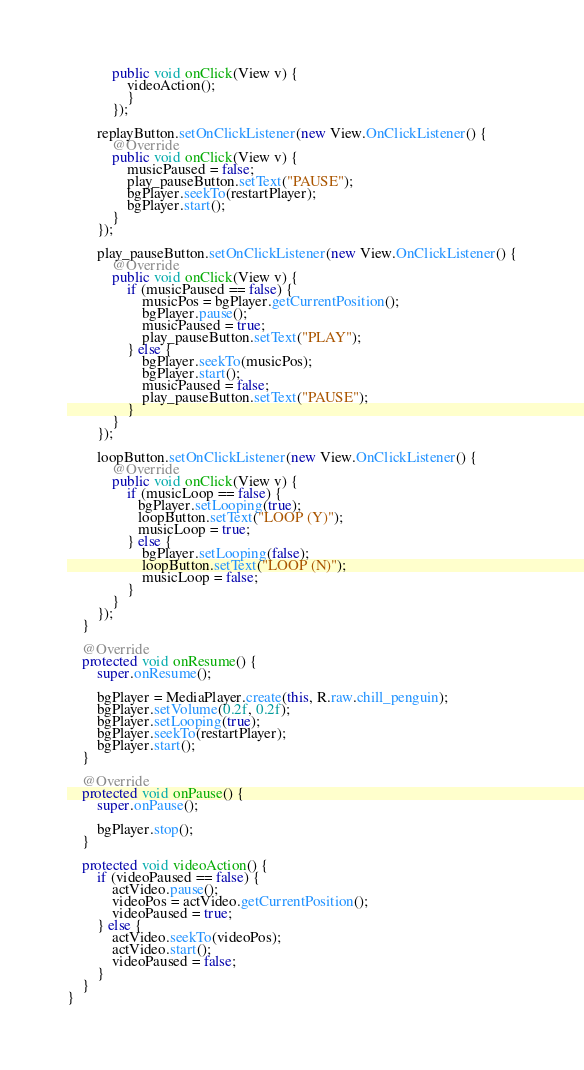<code> <loc_0><loc_0><loc_500><loc_500><_Java_>            public void onClick(View v) {
                videoAction();
                }
            });

        replayButton.setOnClickListener(new View.OnClickListener() {
            @Override
            public void onClick(View v) {
                musicPaused = false;
                play_pauseButton.setText("PAUSE");
                bgPlayer.seekTo(restartPlayer);
                bgPlayer.start();
            }
        });

        play_pauseButton.setOnClickListener(new View.OnClickListener() {
            @Override
            public void onClick(View v) {
                if (musicPaused == false) {
                    musicPos = bgPlayer.getCurrentPosition();
                    bgPlayer.pause();
                    musicPaused = true;
                    play_pauseButton.setText("PLAY");
                } else {
                    bgPlayer.seekTo(musicPos);
                    bgPlayer.start();
                    musicPaused = false;
                    play_pauseButton.setText("PAUSE");
                }
            }
        });

        loopButton.setOnClickListener(new View.OnClickListener() {
            @Override
            public void onClick(View v) {
                if (musicLoop == false) {
                   bgPlayer.setLooping(true);
                   loopButton.setText("LOOP (Y)");
                   musicLoop = true;
                } else {
                    bgPlayer.setLooping(false);
                    loopButton.setText("LOOP (N)");
                    musicLoop = false;
                }
            }
        });
    }

    @Override
    protected void onResume() {
        super.onResume();

        bgPlayer = MediaPlayer.create(this, R.raw.chill_penguin);
        bgPlayer.setVolume(0.2f, 0.2f);
        bgPlayer.setLooping(true);
        bgPlayer.seekTo(restartPlayer);
        bgPlayer.start();
    }

    @Override
    protected void onPause() {
        super.onPause();

        bgPlayer.stop();
    }

    protected void videoAction() {
        if (videoPaused == false) {
            actVideo.pause();
            videoPos = actVideo.getCurrentPosition();
            videoPaused = true;
        } else {
            actVideo.seekTo(videoPos);
            actVideo.start();
            videoPaused = false;
        }
    }
}</code> 